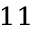<formula> <loc_0><loc_0><loc_500><loc_500>^ { 1 1 }</formula> 